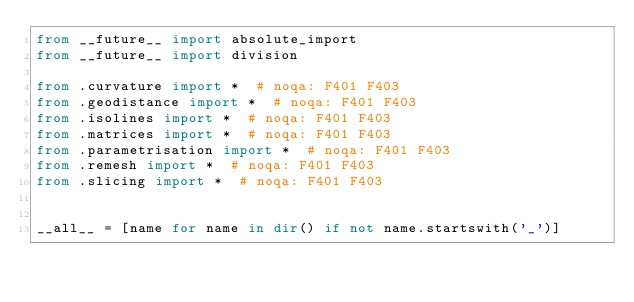<code> <loc_0><loc_0><loc_500><loc_500><_Python_>from __future__ import absolute_import
from __future__ import division

from .curvature import *  # noqa: F401 F403
from .geodistance import *  # noqa: F401 F403
from .isolines import *  # noqa: F401 F403
from .matrices import *  # noqa: F401 F403
from .parametrisation import *  # noqa: F401 F403
from .remesh import *  # noqa: F401 F403
from .slicing import *  # noqa: F401 F403


__all__ = [name for name in dir() if not name.startswith('_')]
</code> 